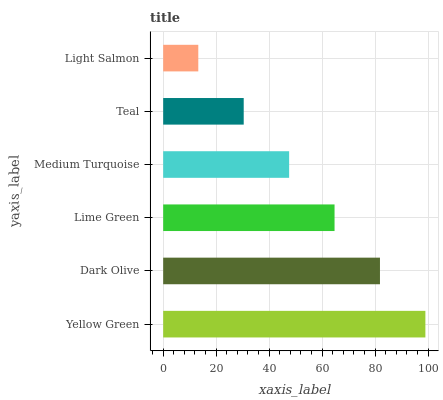Is Light Salmon the minimum?
Answer yes or no. Yes. Is Yellow Green the maximum?
Answer yes or no. Yes. Is Dark Olive the minimum?
Answer yes or no. No. Is Dark Olive the maximum?
Answer yes or no. No. Is Yellow Green greater than Dark Olive?
Answer yes or no. Yes. Is Dark Olive less than Yellow Green?
Answer yes or no. Yes. Is Dark Olive greater than Yellow Green?
Answer yes or no. No. Is Yellow Green less than Dark Olive?
Answer yes or no. No. Is Lime Green the high median?
Answer yes or no. Yes. Is Medium Turquoise the low median?
Answer yes or no. Yes. Is Teal the high median?
Answer yes or no. No. Is Lime Green the low median?
Answer yes or no. No. 